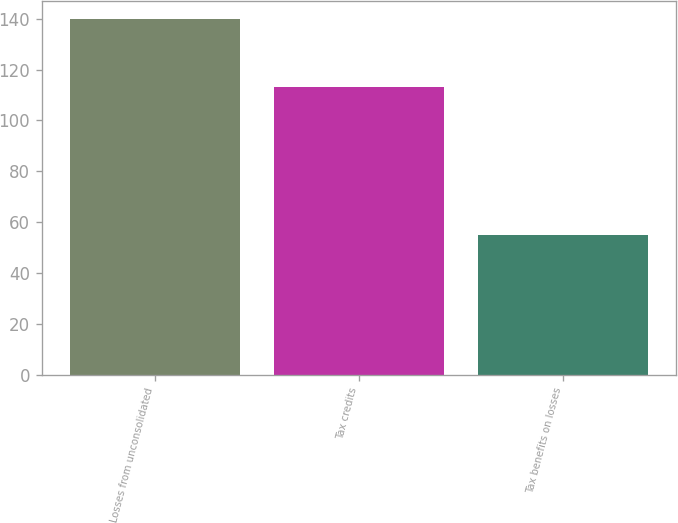<chart> <loc_0><loc_0><loc_500><loc_500><bar_chart><fcel>Losses from unconsolidated<fcel>Tax credits<fcel>Tax benefits on losses<nl><fcel>140<fcel>113<fcel>55<nl></chart> 